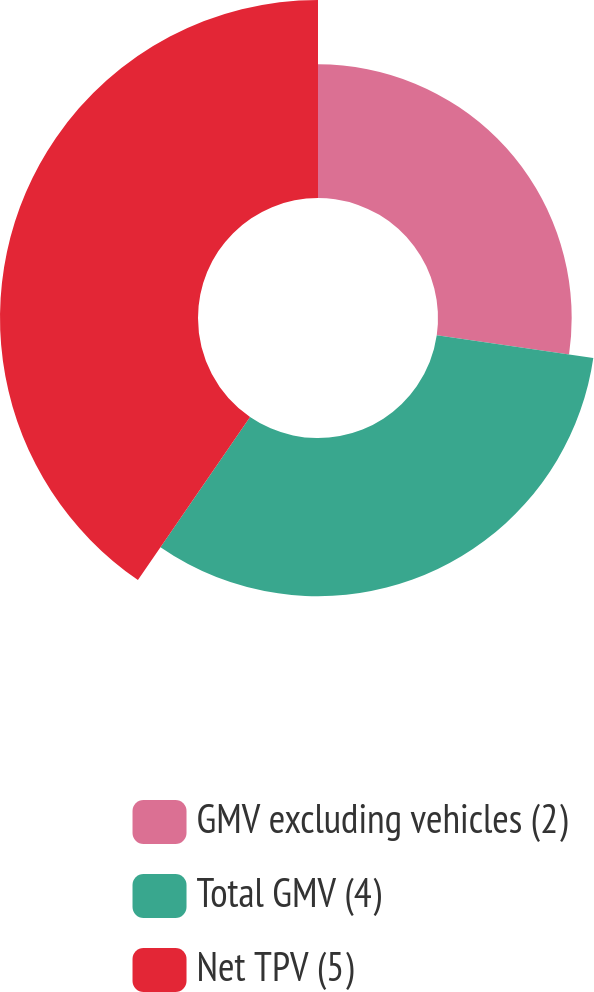<chart> <loc_0><loc_0><loc_500><loc_500><pie_chart><fcel>GMV excluding vehicles (2)<fcel>Total GMV (4)<fcel>Net TPV (5)<nl><fcel>27.29%<fcel>32.29%<fcel>40.42%<nl></chart> 